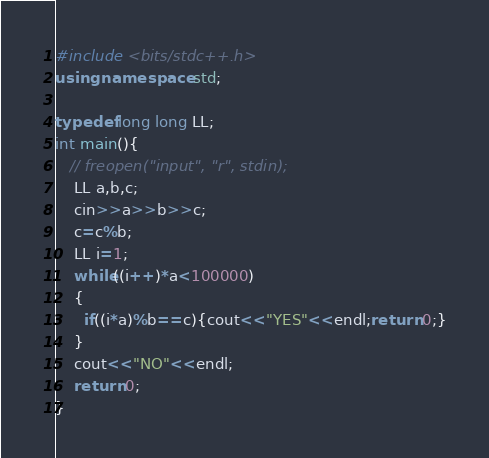<code> <loc_0><loc_0><loc_500><loc_500><_C++_>#include <bits/stdc++.h>
using namespace std;

typedef long long LL;
int main(){
   // freopen("input", "r", stdin);
    LL a,b,c;
    cin>>a>>b>>c;
    c=c%b;
    LL i=1;
    while((i++)*a<100000)
    {
      if((i*a)%b==c){cout<<"YES"<<endl;return 0;}
    }
    cout<<"NO"<<endl;
    return 0;
}
</code> 